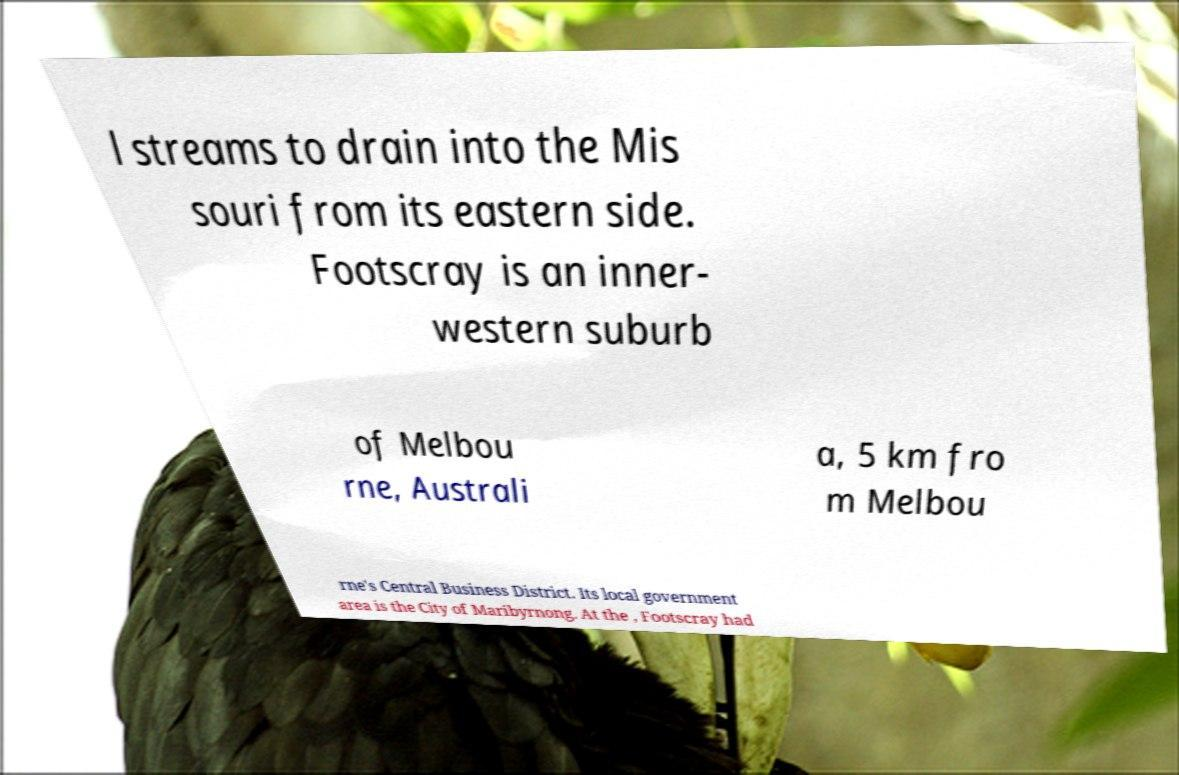There's text embedded in this image that I need extracted. Can you transcribe it verbatim? l streams to drain into the Mis souri from its eastern side. Footscray is an inner- western suburb of Melbou rne, Australi a, 5 km fro m Melbou rne's Central Business District. Its local government area is the City of Maribyrnong. At the , Footscray had 